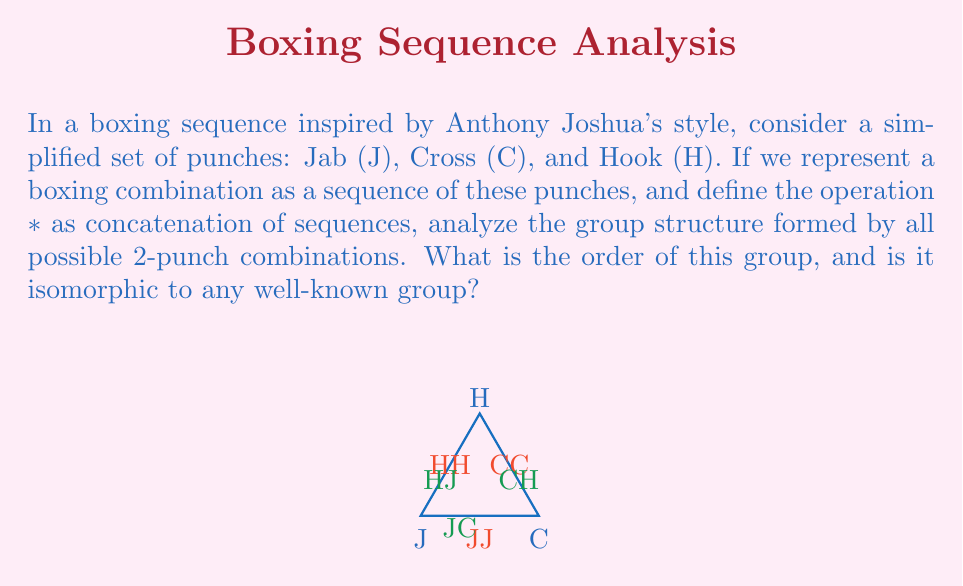Could you help me with this problem? Let's approach this step-by-step:

1) First, we need to identify all possible 2-punch combinations:
   JJ, JC, JH, CJ, CC, CH, HJ, HC, HH

2) There are 9 elements in total, so the order of the group is 9.

3) The operation * is concatenation, which is associative.

4) The identity element is JJ (concatenating JJ with any other element leaves that element unchanged).

5) Each element has an inverse:
   (JJ)^-1 = JJ, (JC)^-1 = CJ, (JH)^-1 = HJ
   (CJ)^-1 = JC, (CC)^-1 = CC, (CH)^-1 = HC
   (HJ)^-1 = JH, (HC)^-1 = CH, (HH)^-1 = HH

6) We can create a Cayley table to visualize the group operation:

   * | JJ JC JH CJ CC CH HJ HC HH
   --+---------------------------
   JJ| JJ JC JH CJ CC CH HJ HC HH
   JC| JC CC CH JJ JC JH CJ CC CH
   JH| JH CH HH CJ CC CH JJ JC JH
   CJ| CJ JC JH CC CH HH JC JH HJ
   CC| CC CH HH JC JH HJ CC CH HH
   CH| CH HH JH JC JH HJ CH HH JJ
   HJ| HJ JH HJ CH HH JJ CC CH HH
   HC| HC HH JJ JH HJ CJ CH HH JJ
   HH| HH JH CJ HJ CJ JC HH JH CJ

7) Looking at this structure, we can see that:
   - There are 3 elements of order 1 (JJ, CC, HH)
   - There are 6 elements of order 2 (JC, JH, CJ, CH, HJ, HC)

8) This structure is identical to the direct product of two cyclic groups of order 3: $C_3 \times C_3$

Therefore, this group is isomorphic to $C_3 \times C_3$.
Answer: Order 9, isomorphic to $C_3 \times C_3$ 